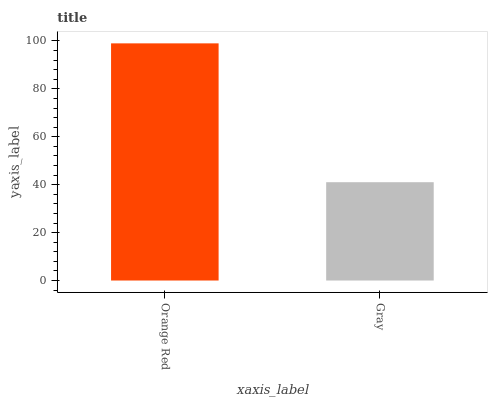Is Gray the minimum?
Answer yes or no. Yes. Is Orange Red the maximum?
Answer yes or no. Yes. Is Gray the maximum?
Answer yes or no. No. Is Orange Red greater than Gray?
Answer yes or no. Yes. Is Gray less than Orange Red?
Answer yes or no. Yes. Is Gray greater than Orange Red?
Answer yes or no. No. Is Orange Red less than Gray?
Answer yes or no. No. Is Orange Red the high median?
Answer yes or no. Yes. Is Gray the low median?
Answer yes or no. Yes. Is Gray the high median?
Answer yes or no. No. Is Orange Red the low median?
Answer yes or no. No. 